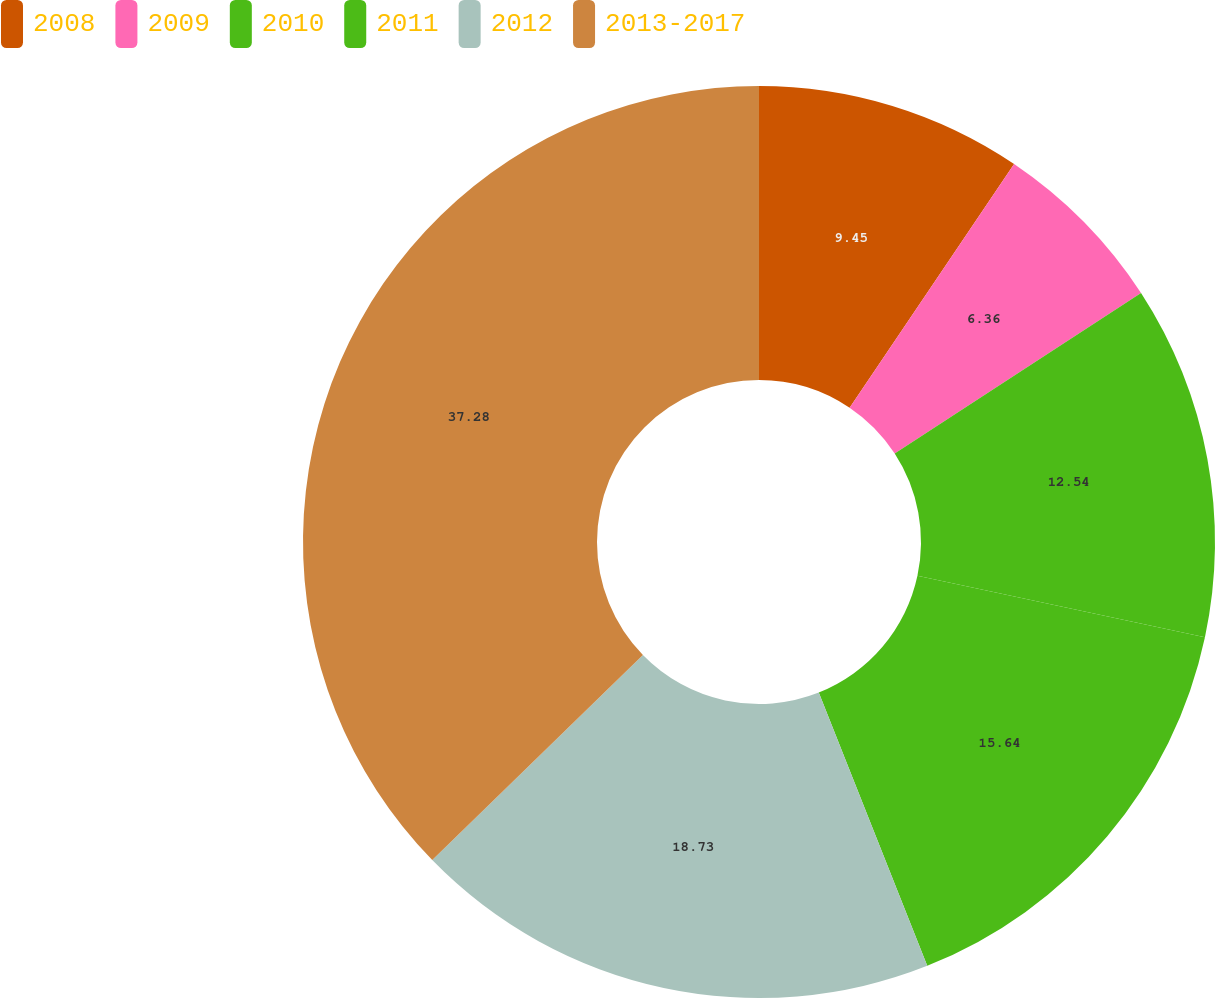Convert chart to OTSL. <chart><loc_0><loc_0><loc_500><loc_500><pie_chart><fcel>2008<fcel>2009<fcel>2010<fcel>2011<fcel>2012<fcel>2013-2017<nl><fcel>9.45%<fcel>6.36%<fcel>12.54%<fcel>15.64%<fcel>18.73%<fcel>37.29%<nl></chart> 